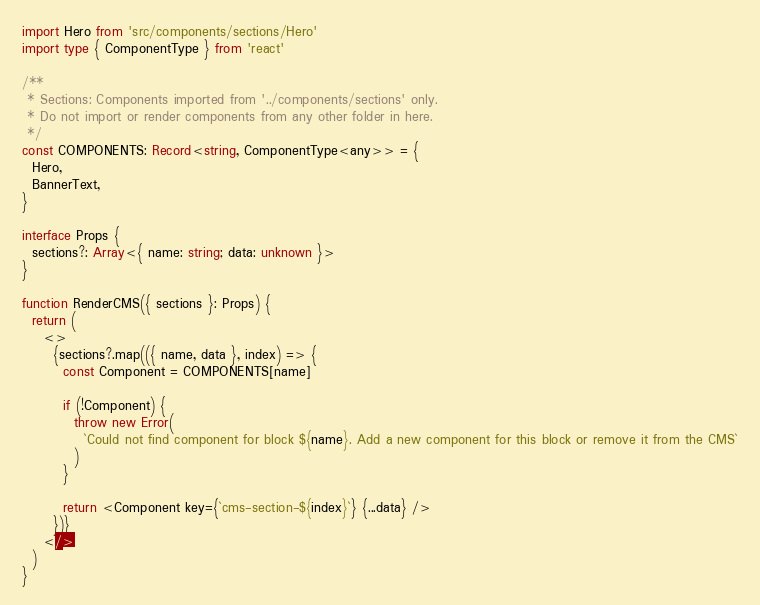<code> <loc_0><loc_0><loc_500><loc_500><_TypeScript_>import Hero from 'src/components/sections/Hero'
import type { ComponentType } from 'react'

/**
 * Sections: Components imported from '../components/sections' only.
 * Do not import or render components from any other folder in here.
 */
const COMPONENTS: Record<string, ComponentType<any>> = {
  Hero,
  BannerText,
}

interface Props {
  sections?: Array<{ name: string; data: unknown }>
}

function RenderCMS({ sections }: Props) {
  return (
    <>
      {sections?.map(({ name, data }, index) => {
        const Component = COMPONENTS[name]

        if (!Component) {
          throw new Error(
            `Could not find component for block ${name}. Add a new component for this block or remove it from the CMS`
          )
        }

        return <Component key={`cms-section-${index}`} {...data} />
      })}
    </>
  )
}
</code> 